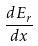<formula> <loc_0><loc_0><loc_500><loc_500>\frac { d E _ { r } } { d x }</formula> 